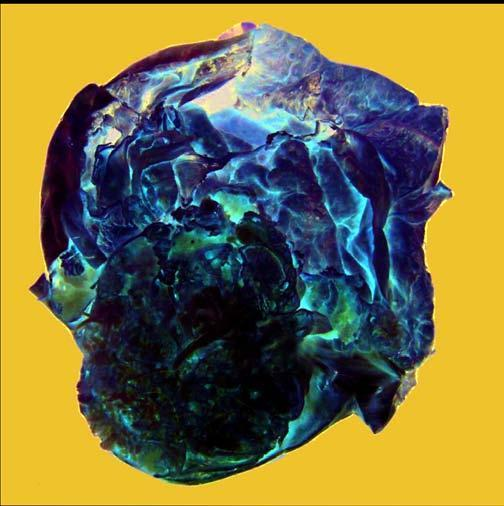does microscopy of the tumour show a very large multilocular cyst without papillae?
Answer the question using a single word or phrase. No 